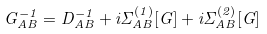Convert formula to latex. <formula><loc_0><loc_0><loc_500><loc_500>G _ { A B } ^ { - 1 } = D _ { A B } ^ { - 1 } + i \Sigma _ { A B } ^ { ( 1 ) } [ G ] + i \Sigma _ { A B } ^ { ( 2 ) } [ G ]</formula> 